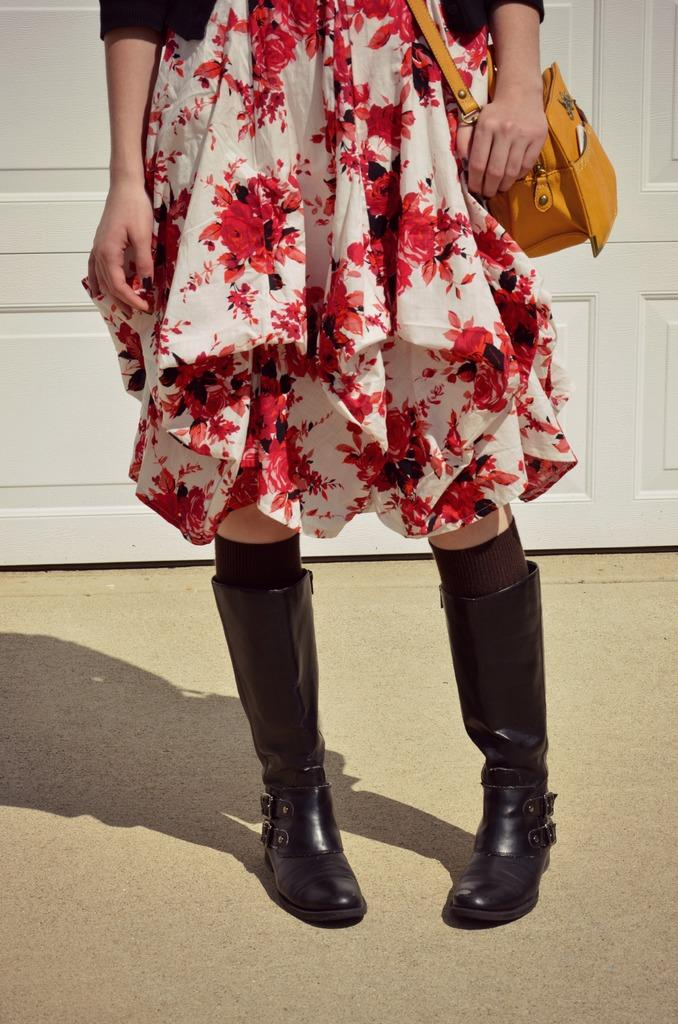Who is the main subject in the image? There is a woman standing in the center of the image. What is the woman carrying in the image? The woman is carrying a handbag. What color is the handbag? The handbag is yellow in color. What can be seen in the background of the image? There is a door visible in the background of the image. Is the woman holding an orange in the image? There is no orange present in the image. Does the woman have an umbrella with her in the image? There is no umbrella visible in the image. 